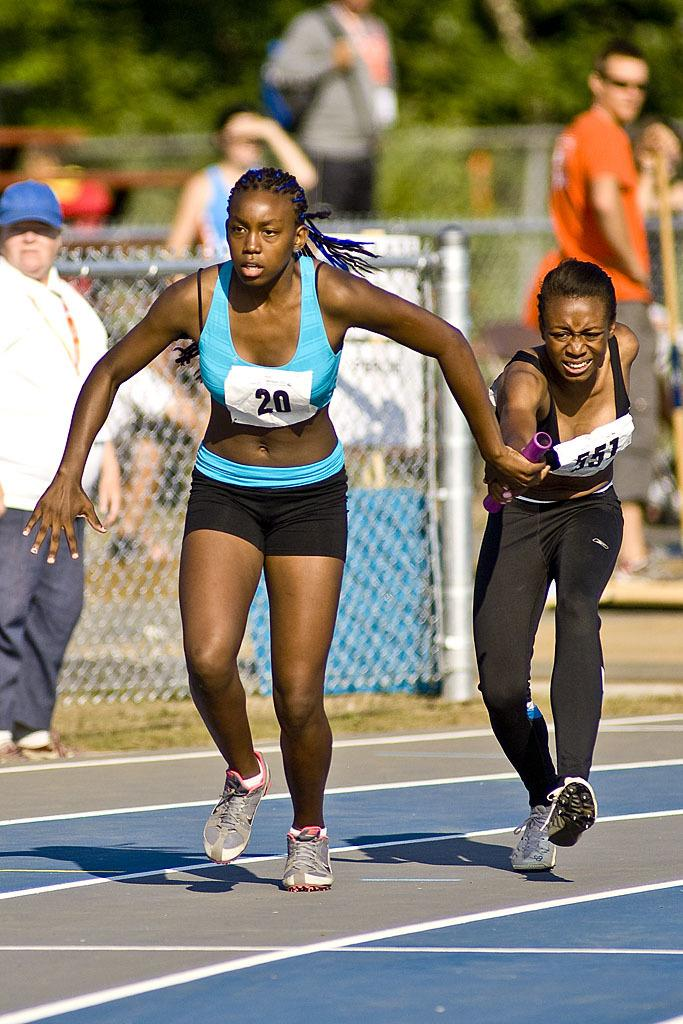How many women are in the image? There are two women in the image. What are the women doing in the image? The women are running in the image. What are the women holding in the image? The women are holding an object in the image. What can be seen in the background of the image? There are meshes and people visible in the background of the image. How would you describe the background of the image? The background has a blurry view. What type of kettle can be seen in the image? There is no kettle present in the image. What kind of beam is supporting the women in the image? The women are running, not being supported by a beam, and there is no beam visible in the image. 